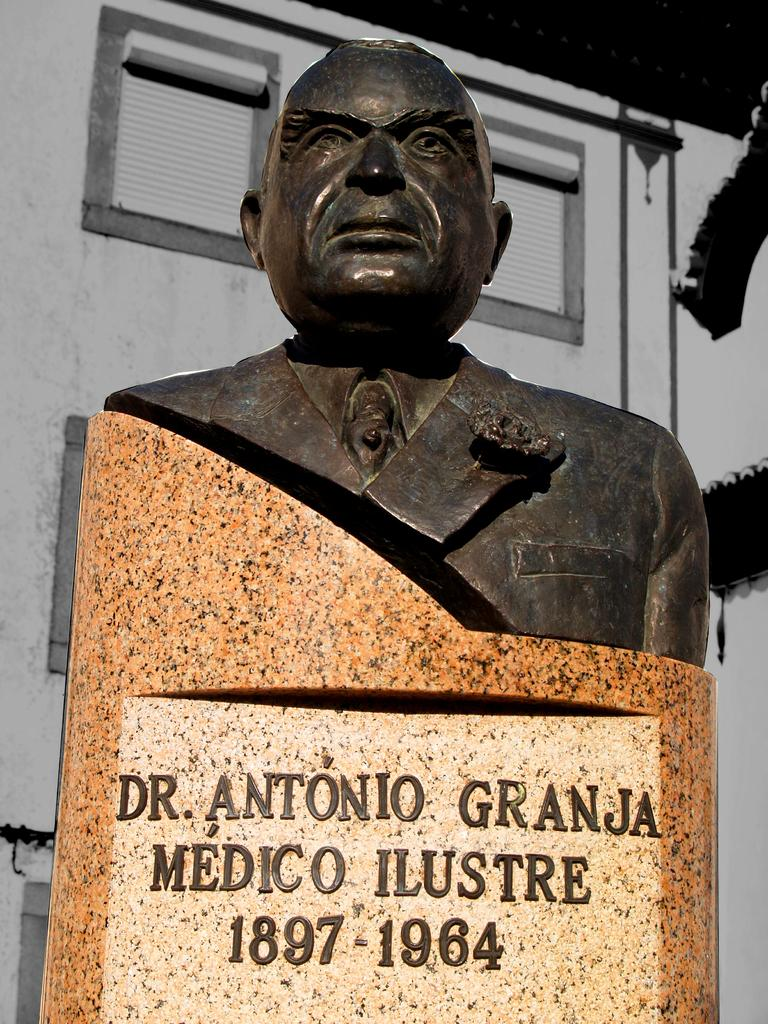What is the main subject in the image? There is a statue in the image. How is the statue positioned in the image? The statue is on a pedestal. Is there any text or information on the pedestal? Yes, there is writing on the pedestal. What can be seen in the background of the image? There is a building in the background of the image. What type of plastic is used to make the berry in the image? There is no berry present in the image, and therefore no plastic material can be associated with it. 